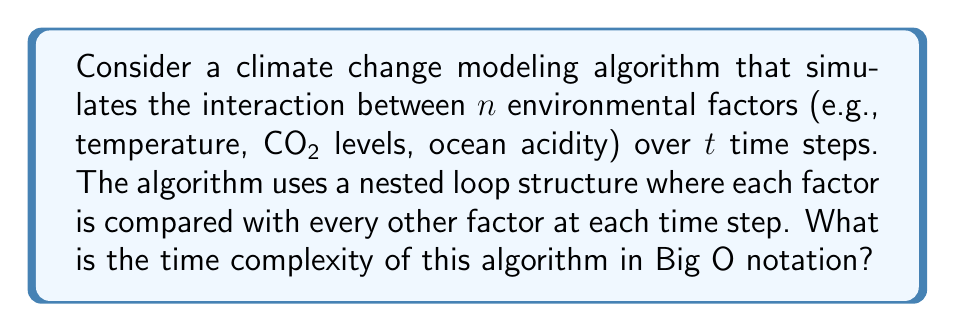Could you help me with this problem? To analyze the time complexity of this algorithm, let's break it down step-by-step:

1. The algorithm has two main components: the time steps and the environmental factors.

2. For each time step (total of $t$ steps):
   - We compare each factor with every other factor.
   - This creates a nested loop structure.

3. The outer loop runs $t$ times (for each time step).

4. For each iteration of the outer loop, we have a nested loop that compares each factor with every other factor:
   - There are $n$ factors in total.
   - Each factor is compared with $(n-1)$ other factors.
   - This results in $n(n-1)$ comparisons.
   - However, if we count each comparison only once (A compared to B is the same as B compared to A), we have $\frac{n(n-1)}{2}$ comparisons.

5. The total number of operations is therefore:

   $$t \cdot \frac{n(n-1)}{2}$$

6. Expanding this expression:

   $$\frac{tn^2 - tn}{2}$$

7. In Big O notation, we focus on the highest order term and drop constant factors. The highest order term here is $tn^2$.

8. Therefore, the time complexity of this algorithm is $O(tn^2)$.

This quadratic time complexity in terms of the number of environmental factors indicates that the algorithm's running time will increase significantly as we add more factors to the model, which is crucial to consider when dealing with complex climate systems.
Answer: $O(tn^2)$ 